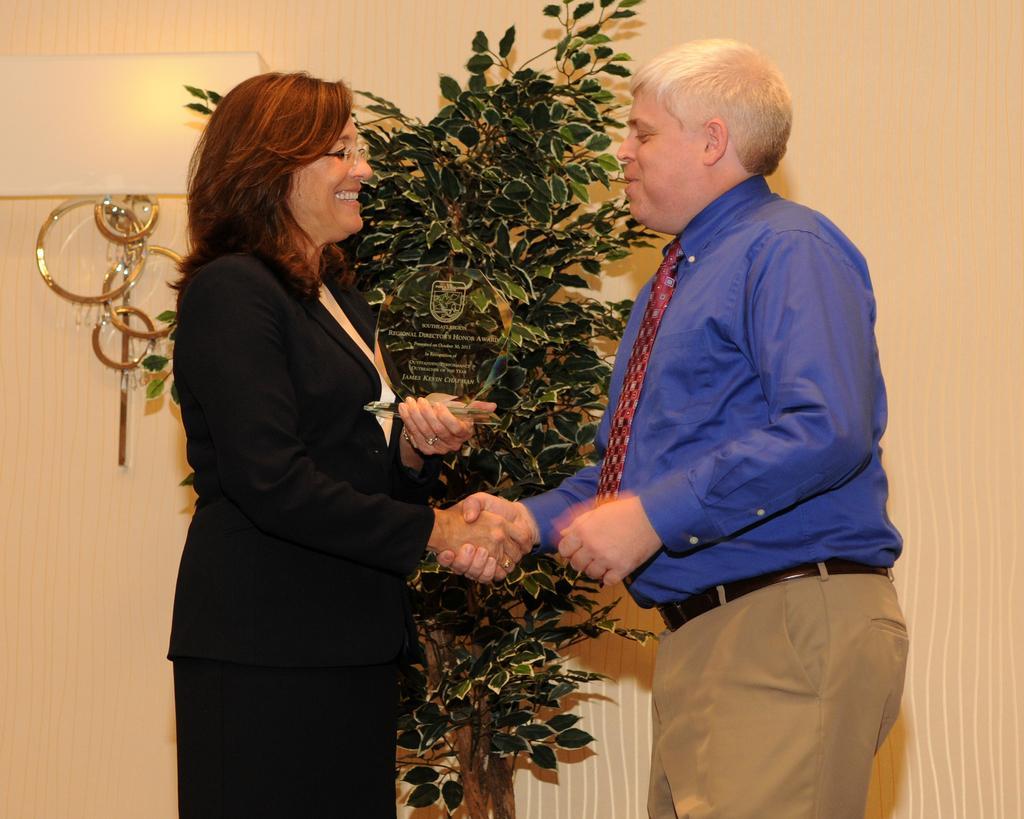Can you describe this image briefly? There is a woman and a man,both are greeting each other and the woman is wearing black blazer and the man is wearing blue shirt. Behind these two people there is a plant and in the background there is a wall. 